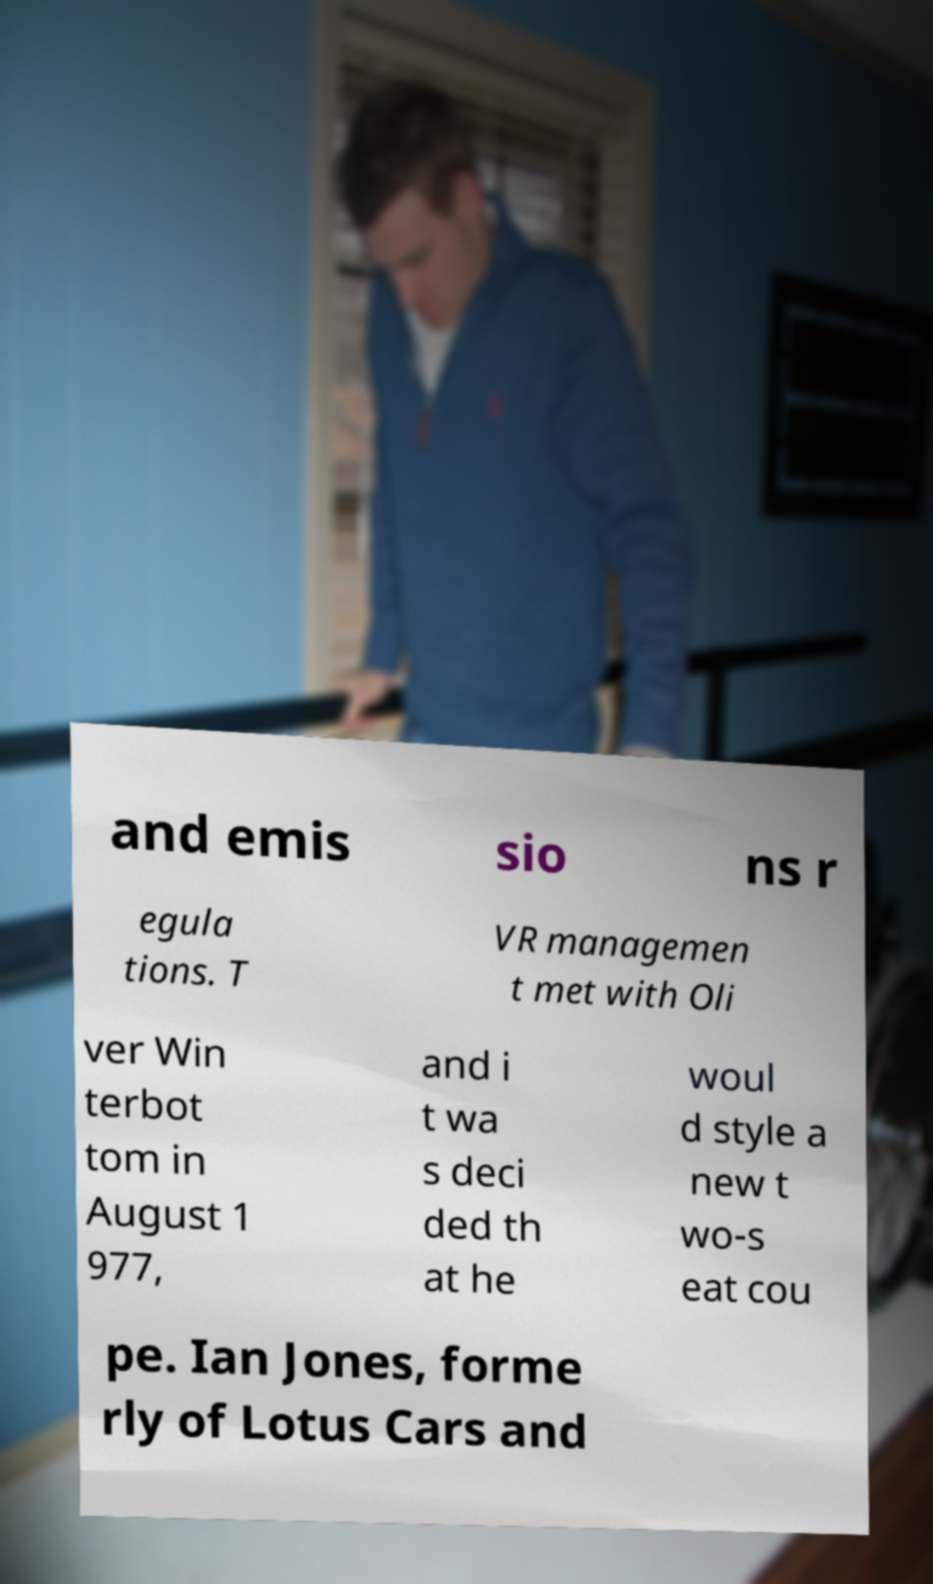I need the written content from this picture converted into text. Can you do that? and emis sio ns r egula tions. T VR managemen t met with Oli ver Win terbot tom in August 1 977, and i t wa s deci ded th at he woul d style a new t wo-s eat cou pe. Ian Jones, forme rly of Lotus Cars and 